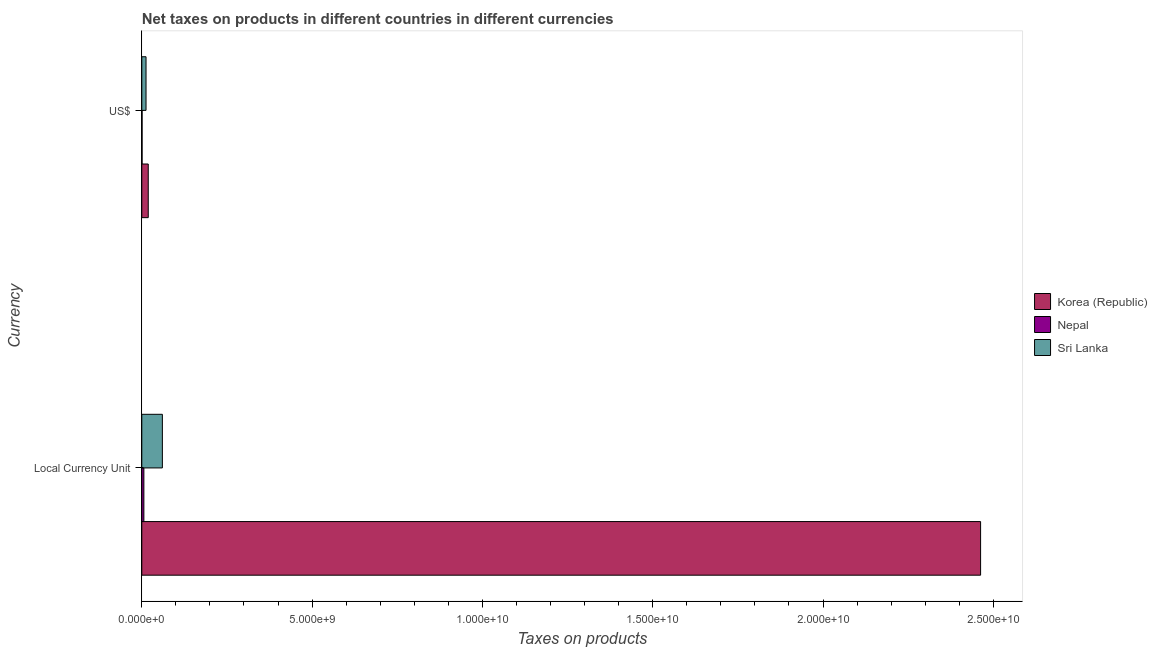How many different coloured bars are there?
Your answer should be very brief. 3. How many groups of bars are there?
Provide a short and direct response. 2. How many bars are there on the 1st tick from the top?
Provide a short and direct response. 3. How many bars are there on the 2nd tick from the bottom?
Your answer should be very brief. 3. What is the label of the 2nd group of bars from the top?
Your answer should be very brief. Local Currency Unit. What is the net taxes in us$ in Sri Lanka?
Provide a short and direct response. 1.24e+08. Across all countries, what is the maximum net taxes in us$?
Provide a short and direct response. 1.89e+08. Across all countries, what is the minimum net taxes in constant 2005 us$?
Give a very brief answer. 6.10e+07. In which country was the net taxes in constant 2005 us$ minimum?
Your response must be concise. Nepal. What is the total net taxes in us$ in the graph?
Keep it short and to the point. 3.22e+08. What is the difference between the net taxes in constant 2005 us$ in Nepal and that in Korea (Republic)?
Give a very brief answer. -2.46e+1. What is the difference between the net taxes in us$ in Korea (Republic) and the net taxes in constant 2005 us$ in Nepal?
Offer a terse response. 1.28e+08. What is the average net taxes in us$ per country?
Offer a terse response. 1.07e+08. What is the difference between the net taxes in us$ and net taxes in constant 2005 us$ in Korea (Republic)?
Offer a very short reply. -2.44e+1. In how many countries, is the net taxes in constant 2005 us$ greater than 14000000000 units?
Give a very brief answer. 1. What is the ratio of the net taxes in us$ in Sri Lanka to that in Nepal?
Give a very brief answer. 15.52. What does the 3rd bar from the top in Local Currency Unit represents?
Provide a succinct answer. Korea (Republic). What does the 2nd bar from the bottom in Local Currency Unit represents?
Ensure brevity in your answer.  Nepal. Are all the bars in the graph horizontal?
Offer a terse response. Yes. What is the difference between two consecutive major ticks on the X-axis?
Give a very brief answer. 5.00e+09. Are the values on the major ticks of X-axis written in scientific E-notation?
Provide a short and direct response. Yes. Does the graph contain any zero values?
Keep it short and to the point. No. Where does the legend appear in the graph?
Your response must be concise. Center right. What is the title of the graph?
Your answer should be very brief. Net taxes on products in different countries in different currencies. Does "Myanmar" appear as one of the legend labels in the graph?
Offer a terse response. No. What is the label or title of the X-axis?
Keep it short and to the point. Taxes on products. What is the label or title of the Y-axis?
Ensure brevity in your answer.  Currency. What is the Taxes on products of Korea (Republic) in Local Currency Unit?
Ensure brevity in your answer.  2.46e+1. What is the Taxes on products of Nepal in Local Currency Unit?
Provide a succinct answer. 6.10e+07. What is the Taxes on products of Sri Lanka in Local Currency Unit?
Offer a terse response. 6.04e+08. What is the Taxes on products in Korea (Republic) in US$?
Your answer should be very brief. 1.89e+08. What is the Taxes on products in Nepal in US$?
Your answer should be compact. 8.01e+06. What is the Taxes on products in Sri Lanka in US$?
Make the answer very short. 1.24e+08. Across all Currency, what is the maximum Taxes on products in Korea (Republic)?
Keep it short and to the point. 2.46e+1. Across all Currency, what is the maximum Taxes on products in Nepal?
Your answer should be compact. 6.10e+07. Across all Currency, what is the maximum Taxes on products of Sri Lanka?
Offer a very short reply. 6.04e+08. Across all Currency, what is the minimum Taxes on products of Korea (Republic)?
Provide a succinct answer. 1.89e+08. Across all Currency, what is the minimum Taxes on products of Nepal?
Give a very brief answer. 8.01e+06. Across all Currency, what is the minimum Taxes on products of Sri Lanka?
Provide a short and direct response. 1.24e+08. What is the total Taxes on products of Korea (Republic) in the graph?
Offer a very short reply. 2.48e+1. What is the total Taxes on products in Nepal in the graph?
Give a very brief answer. 6.90e+07. What is the total Taxes on products of Sri Lanka in the graph?
Offer a very short reply. 7.28e+08. What is the difference between the Taxes on products in Korea (Republic) in Local Currency Unit and that in US$?
Offer a terse response. 2.44e+1. What is the difference between the Taxes on products of Nepal in Local Currency Unit and that in US$?
Provide a short and direct response. 5.30e+07. What is the difference between the Taxes on products in Sri Lanka in Local Currency Unit and that in US$?
Provide a succinct answer. 4.80e+08. What is the difference between the Taxes on products of Korea (Republic) in Local Currency Unit and the Taxes on products of Nepal in US$?
Offer a terse response. 2.46e+1. What is the difference between the Taxes on products in Korea (Republic) in Local Currency Unit and the Taxes on products in Sri Lanka in US$?
Ensure brevity in your answer.  2.45e+1. What is the difference between the Taxes on products in Nepal in Local Currency Unit and the Taxes on products in Sri Lanka in US$?
Your response must be concise. -6.33e+07. What is the average Taxes on products of Korea (Republic) per Currency?
Your answer should be compact. 1.24e+1. What is the average Taxes on products of Nepal per Currency?
Provide a succinct answer. 3.45e+07. What is the average Taxes on products of Sri Lanka per Currency?
Make the answer very short. 3.64e+08. What is the difference between the Taxes on products in Korea (Republic) and Taxes on products in Nepal in Local Currency Unit?
Keep it short and to the point. 2.46e+1. What is the difference between the Taxes on products in Korea (Republic) and Taxes on products in Sri Lanka in Local Currency Unit?
Provide a short and direct response. 2.40e+1. What is the difference between the Taxes on products of Nepal and Taxes on products of Sri Lanka in Local Currency Unit?
Provide a succinct answer. -5.43e+08. What is the difference between the Taxes on products in Korea (Republic) and Taxes on products in Nepal in US$?
Make the answer very short. 1.81e+08. What is the difference between the Taxes on products of Korea (Republic) and Taxes on products of Sri Lanka in US$?
Your response must be concise. 6.52e+07. What is the difference between the Taxes on products of Nepal and Taxes on products of Sri Lanka in US$?
Ensure brevity in your answer.  -1.16e+08. What is the ratio of the Taxes on products of Korea (Republic) in Local Currency Unit to that in US$?
Provide a short and direct response. 130. What is the ratio of the Taxes on products in Nepal in Local Currency Unit to that in US$?
Give a very brief answer. 7.62. What is the ratio of the Taxes on products in Sri Lanka in Local Currency Unit to that in US$?
Your answer should be compact. 4.86. What is the difference between the highest and the second highest Taxes on products in Korea (Republic)?
Your response must be concise. 2.44e+1. What is the difference between the highest and the second highest Taxes on products in Nepal?
Provide a short and direct response. 5.30e+07. What is the difference between the highest and the second highest Taxes on products in Sri Lanka?
Your answer should be very brief. 4.80e+08. What is the difference between the highest and the lowest Taxes on products in Korea (Republic)?
Ensure brevity in your answer.  2.44e+1. What is the difference between the highest and the lowest Taxes on products of Nepal?
Make the answer very short. 5.30e+07. What is the difference between the highest and the lowest Taxes on products of Sri Lanka?
Provide a succinct answer. 4.80e+08. 